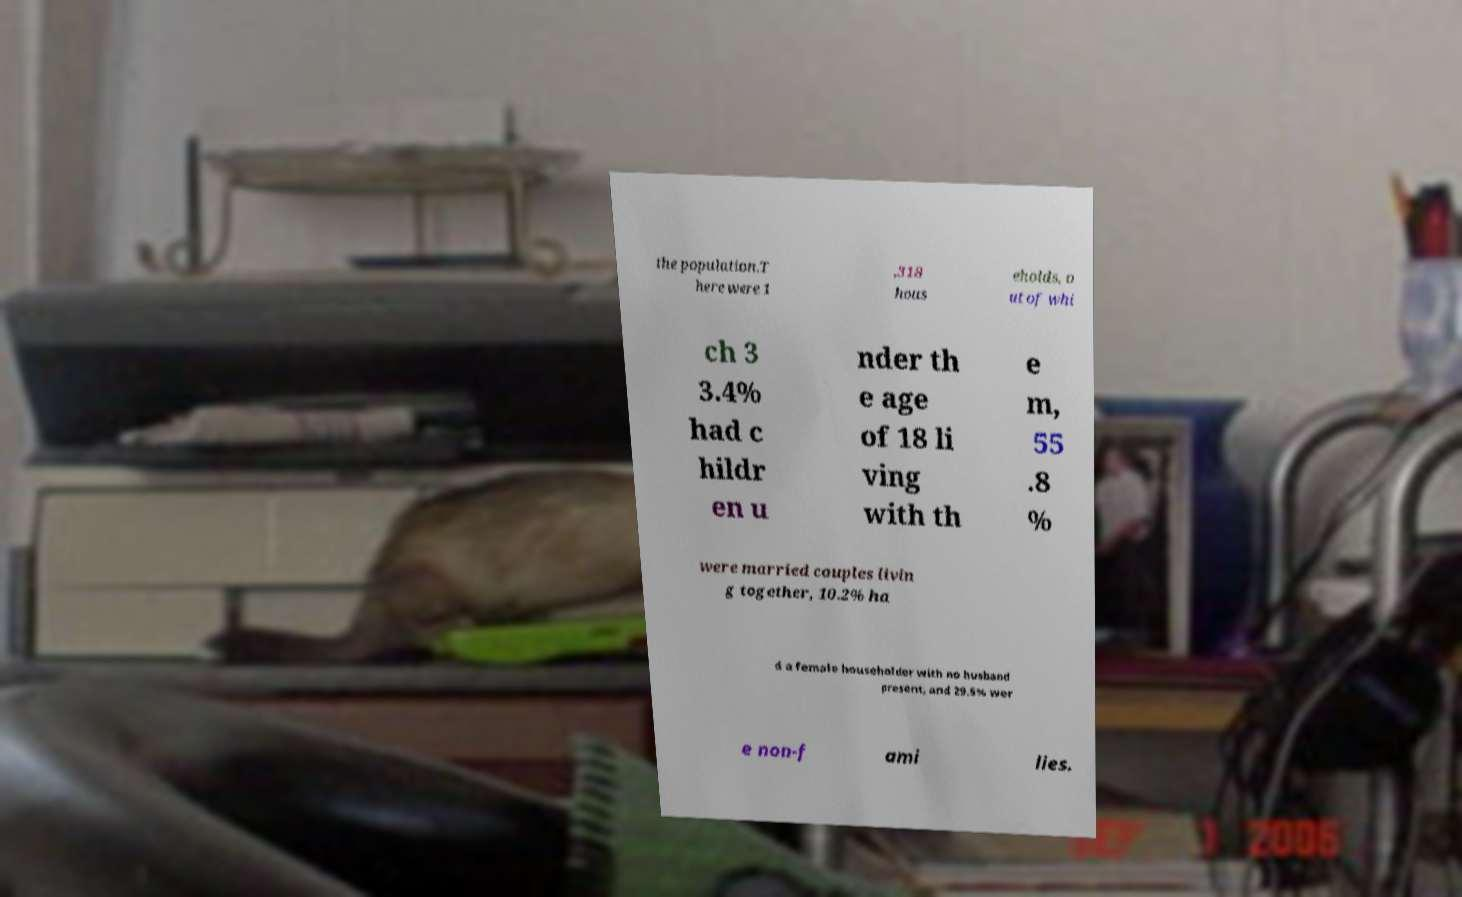For documentation purposes, I need the text within this image transcribed. Could you provide that? the population.T here were 1 ,318 hous eholds, o ut of whi ch 3 3.4% had c hildr en u nder th e age of 18 li ving with th e m, 55 .8 % were married couples livin g together, 10.2% ha d a female householder with no husband present, and 29.5% wer e non-f ami lies. 